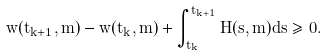<formula> <loc_0><loc_0><loc_500><loc_500>w ( t _ { k + 1 } , m ) - w ( t _ { k } , m ) + \int _ { t _ { k } } ^ { t _ { k + 1 } } H ( s , m ) d s \geq 0 .</formula> 